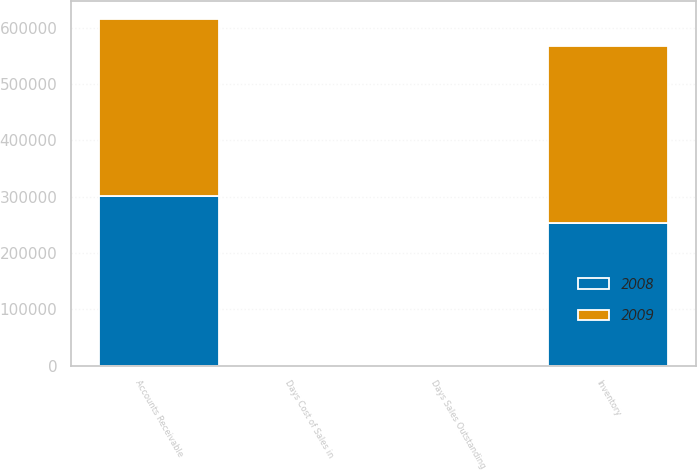Convert chart. <chart><loc_0><loc_0><loc_500><loc_500><stacked_bar_chart><ecel><fcel>Accounts Receivable<fcel>Days Sales Outstanding<fcel>Inventory<fcel>Days Cost of Sales in<nl><fcel>2008<fcel>301036<fcel>48<fcel>253161<fcel>92<nl><fcel>2009<fcel>315290<fcel>44<fcel>314629<fcel>112<nl></chart> 